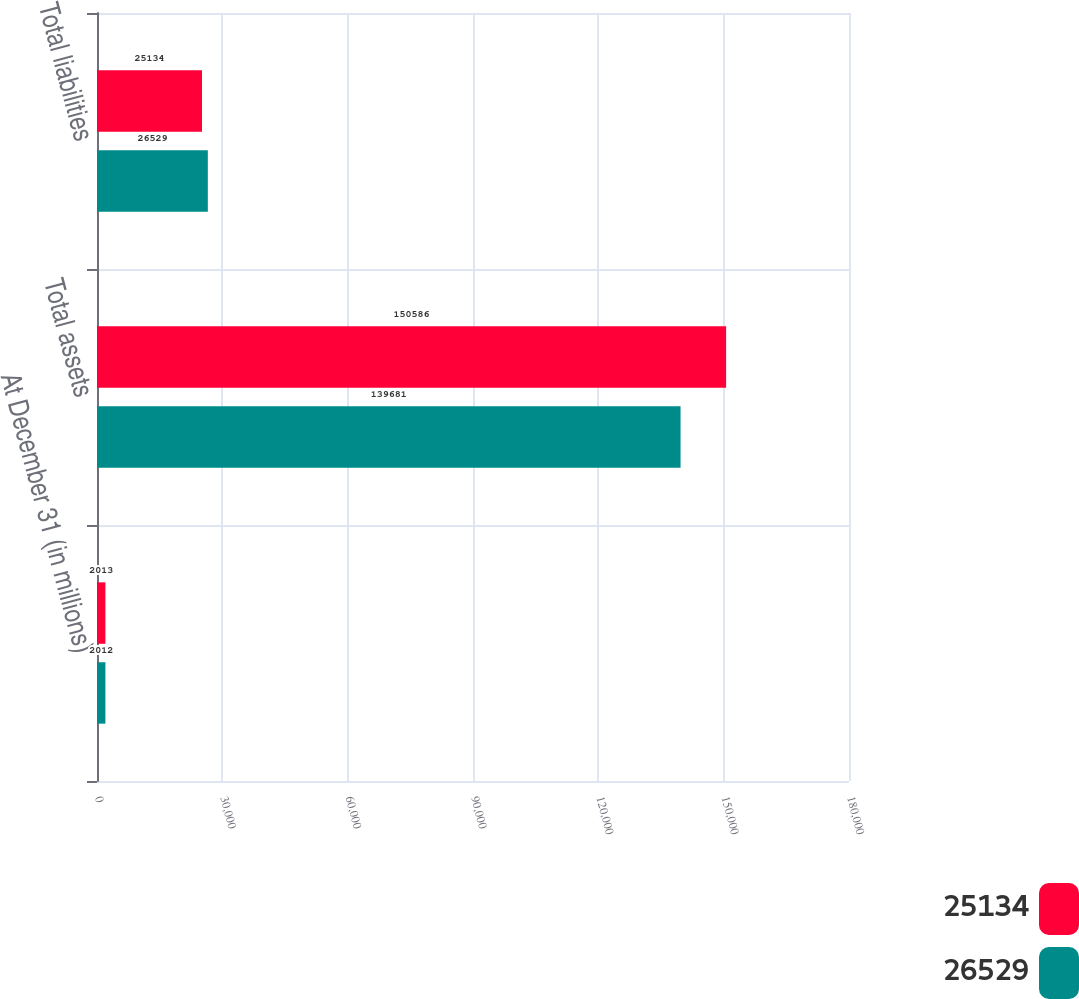Convert chart to OTSL. <chart><loc_0><loc_0><loc_500><loc_500><stacked_bar_chart><ecel><fcel>At December 31 (in millions)<fcel>Total assets<fcel>Total liabilities<nl><fcel>25134<fcel>2013<fcel>150586<fcel>25134<nl><fcel>26529<fcel>2012<fcel>139681<fcel>26529<nl></chart> 